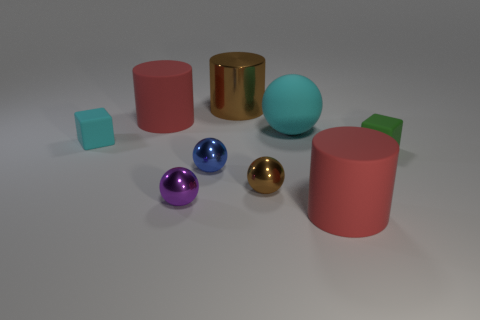Subtract all cubes. How many objects are left? 7 Add 1 tiny purple shiny spheres. How many tiny purple shiny spheres are left? 2 Add 1 large cyan rubber objects. How many large cyan rubber objects exist? 2 Subtract 1 blue balls. How many objects are left? 8 Subtract all purple metal spheres. Subtract all red cylinders. How many objects are left? 6 